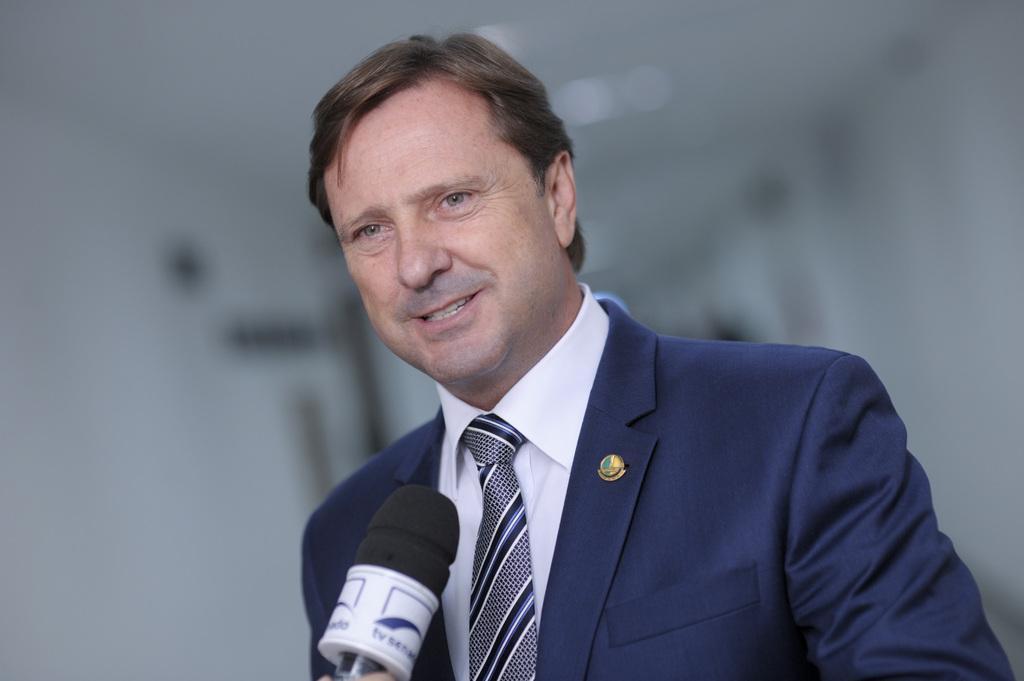Can you describe this image briefly? In this image I can see a person wearing white shirt, blue tie and blue blazer is smiling and I can see a microphone in front of him. I can see the blurry background which is white in color. 